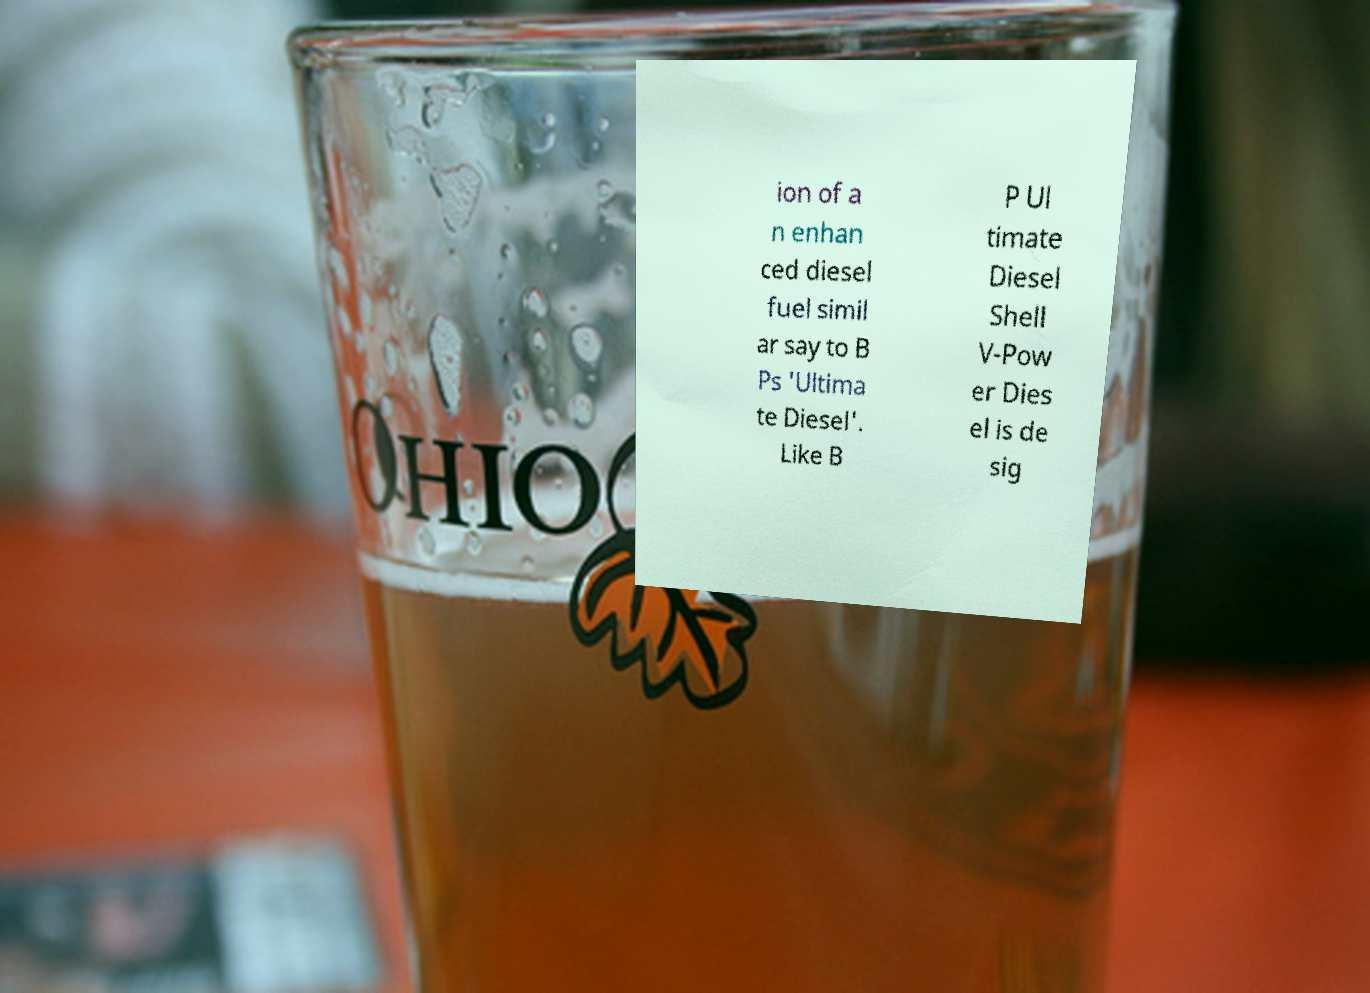Can you accurately transcribe the text from the provided image for me? ion of a n enhan ced diesel fuel simil ar say to B Ps 'Ultima te Diesel'. Like B P Ul timate Diesel Shell V-Pow er Dies el is de sig 